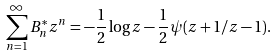Convert formula to latex. <formula><loc_0><loc_0><loc_500><loc_500>\sum _ { n = 1 } ^ { \infty } B _ { n } ^ { * } z ^ { n } = - \frac { 1 } { 2 } \log z - \frac { 1 } { 2 } \psi ( z + 1 / z - 1 ) .</formula> 